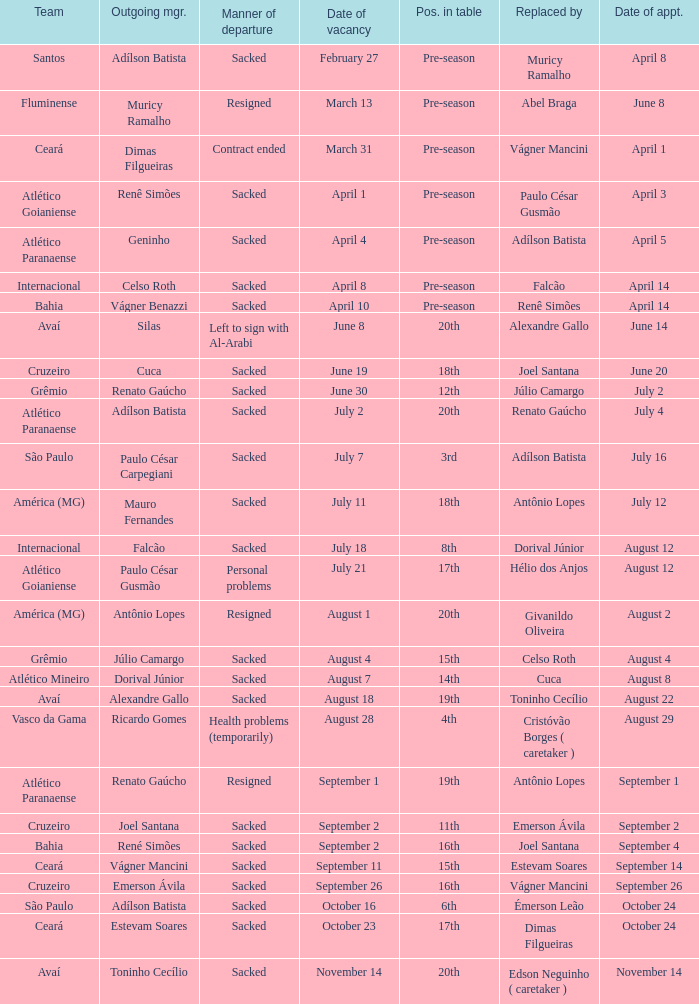What team hired Renato Gaúcho? Atlético Paranaense. 